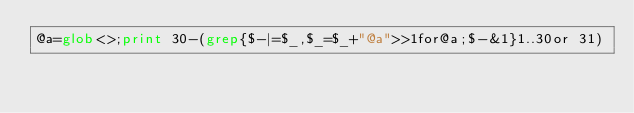<code> <loc_0><loc_0><loc_500><loc_500><_Perl_>@a=glob<>;print 30-(grep{$-|=$_,$_=$_+"@a">>1for@a;$-&1}1..30or 31)</code> 